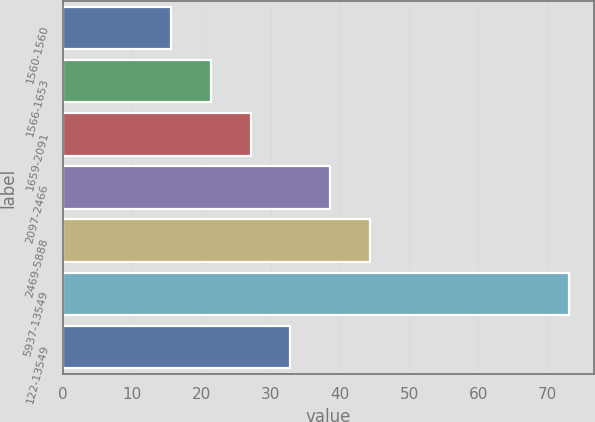Convert chart to OTSL. <chart><loc_0><loc_0><loc_500><loc_500><bar_chart><fcel>1560-1560<fcel>1566-1653<fcel>1659-2091<fcel>2097-2466<fcel>2469-5888<fcel>5937-13549<fcel>122-13549<nl><fcel>15.6<fcel>21.35<fcel>27.1<fcel>38.6<fcel>44.35<fcel>73.06<fcel>32.85<nl></chart> 